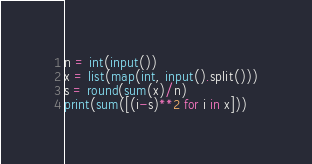<code> <loc_0><loc_0><loc_500><loc_500><_Python_>n = int(input())
x = list(map(int, input().split()))
s = round(sum(x)/n)
print(sum([(i-s)**2 for i in x]))</code> 